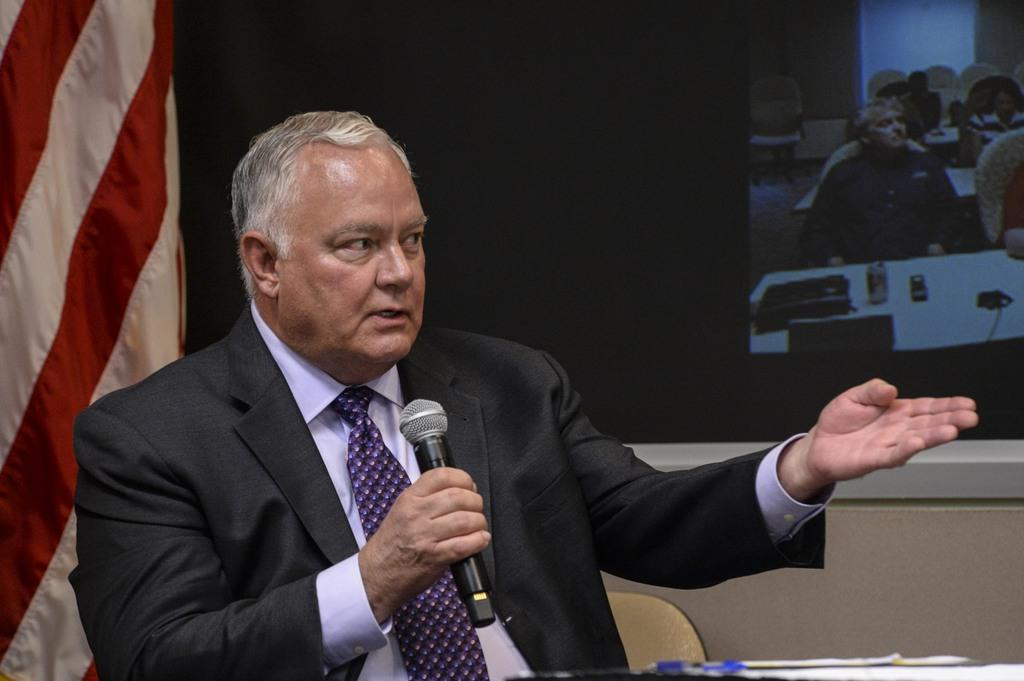What is the person in the image doing? The person is sitting on a chair and holding a mic. What is the person wearing around their neck? The person is wearing a tie. What can be seen in the background of the image? There is a projector and a flag in the background. What type of hammer can be seen in the person's hand in the image? There is no hammer present in the image; the person is holding a mic. What kind of shop can be seen in the background of the image? There is no shop visible in the image; the background features a projector and a flag. 